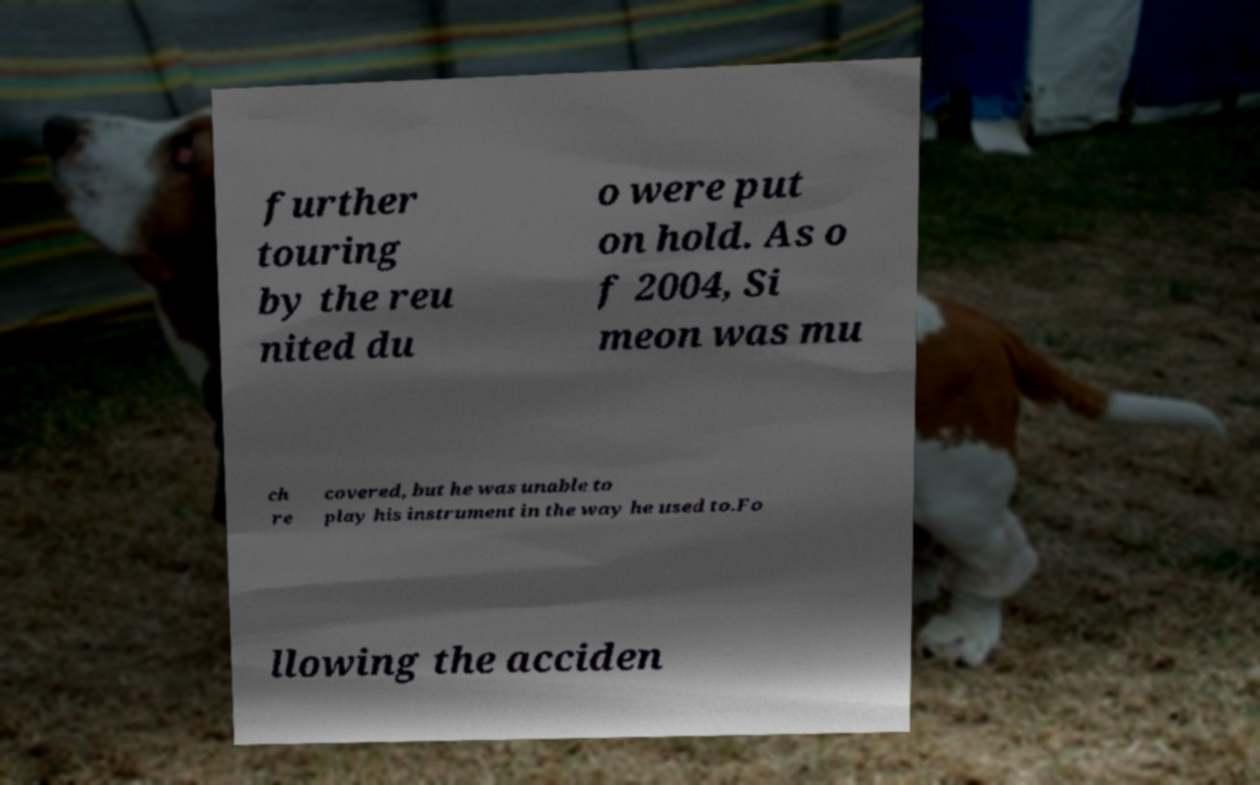What messages or text are displayed in this image? I need them in a readable, typed format. further touring by the reu nited du o were put on hold. As o f 2004, Si meon was mu ch re covered, but he was unable to play his instrument in the way he used to.Fo llowing the acciden 